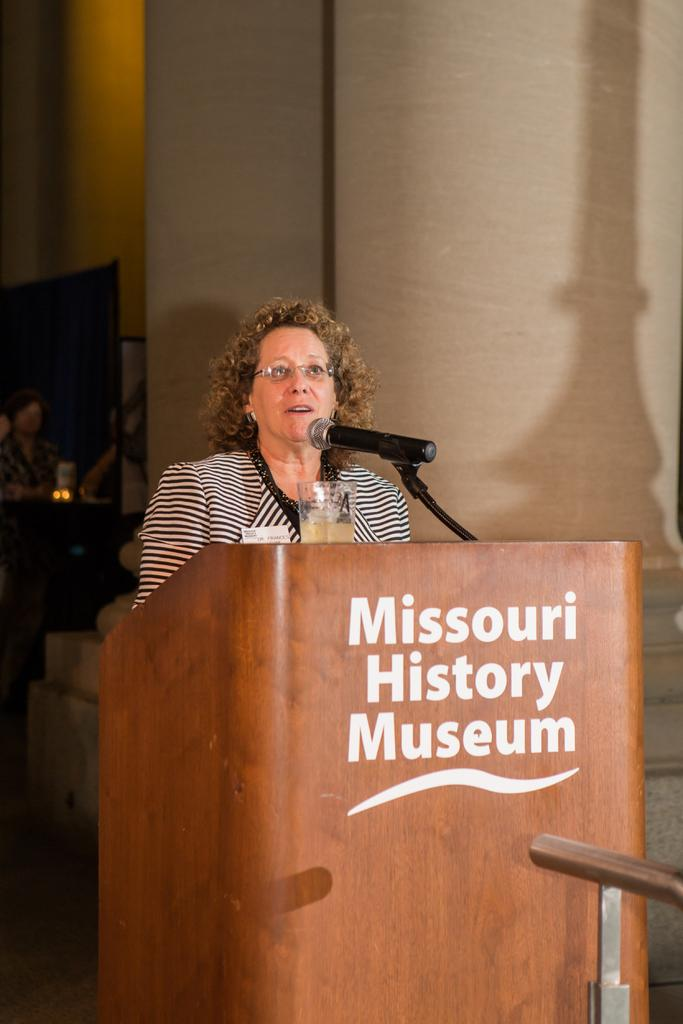Who is the main subject in the image? There is a woman in the image. What is the woman standing in front of? There is a podium in front of the woman. What is on top of the podium? There is a microphone and a glass above the podium. What can be seen in the background of the image? There is a wall and a person in the background of the image. What flavor of ice cream is being served on the mountain in the image? There is no ice cream or mountain present in the image. 